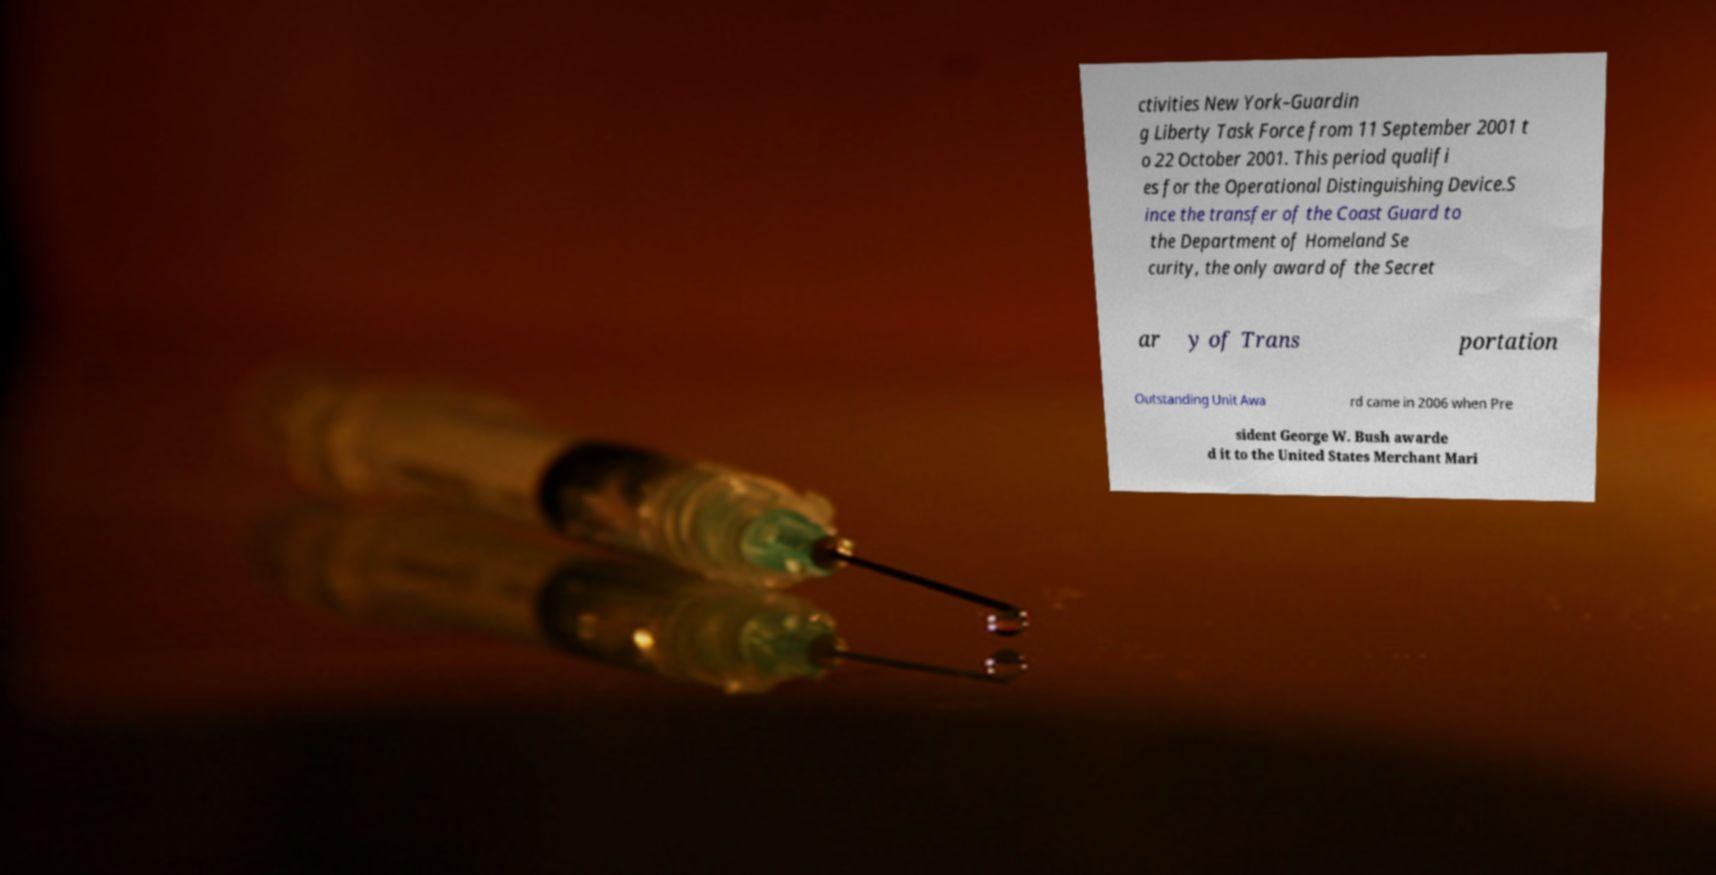For documentation purposes, I need the text within this image transcribed. Could you provide that? ctivities New York–Guardin g Liberty Task Force from 11 September 2001 t o 22 October 2001. This period qualifi es for the Operational Distinguishing Device.S ince the transfer of the Coast Guard to the Department of Homeland Se curity, the only award of the Secret ar y of Trans portation Outstanding Unit Awa rd came in 2006 when Pre sident George W. Bush awarde d it to the United States Merchant Mari 